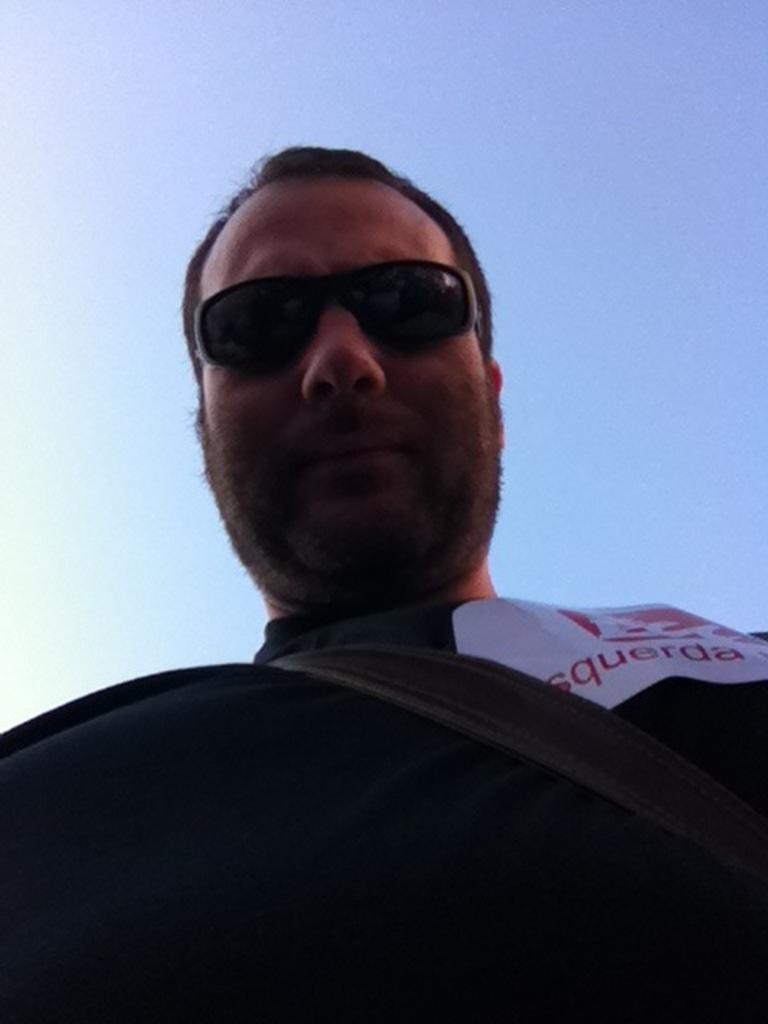How would you summarize this image in a sentence or two? In the image there is a man with black t-shirt and a bag strap. He kept goggles. Behind him there is a sky. 